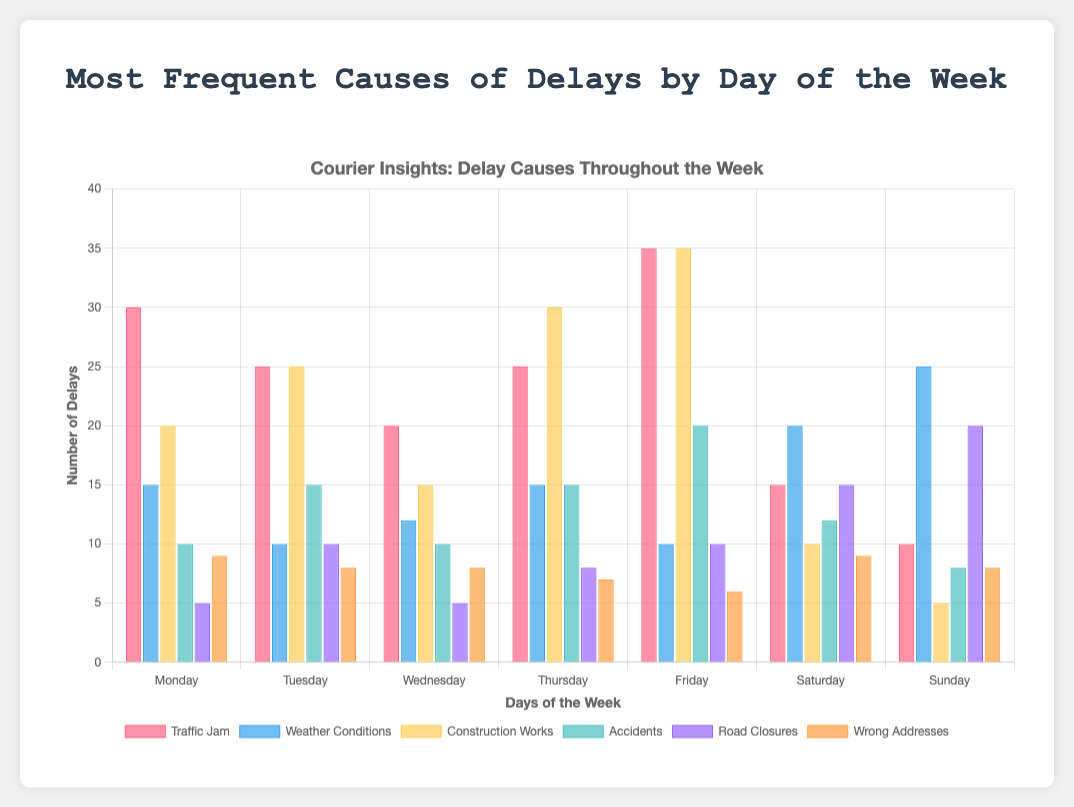What is the most frequent cause of delays on Monday? By looking at the height of the bars for Monday, the tallest bar represents "Traffic Jam" with a frequency of 30.
Answer: Traffic Jam Which day has the highest number of delays caused by Weather Conditions? By comparing the heights of the bars for Weather Conditions across all days, Sunday has the tallest bar with a frequency of 25.
Answer: Sunday What is the total number of delays caused by Construction Works from Monday to Sunday? Sum up the values for Construction Works across all days: 20 + 25 + 15 + 30 + 35 + 10 + 5 = 140.
Answer: 140 Between Tuesday and Thursday, which day has more delays due to Accidents? Compare the heights of the bars for Accidents on Tuesday (15) and Thursday (15). Both are equal.
Answer: Equal How do the number of delays due to Wrong Addresses compare between Monday and Saturday? Compare the height of the bars for Wrong Addresses on Monday (9) and Saturday (9). Both are equal.
Answer: Equal Which cause of delay has the least frequency on Sunday? By looking at the heights of all bars for Sunday, the shortest bar represents Construction Works with a frequency of 5.
Answer: Construction Works What is the average number of delays caused by Road Closures across the week? Sum up all values for Road Closures and divide by 7: (5 + 10 + 5 + 8 + 10 + 15 + 20) / 7 = 73 / 7 ≈ 10.43.
Answer: 10.43 On which day does Traffic Jam cause the smallest number of delays? Compare the height of the bars for Traffic Jam across all days. The shortest bar is on Sunday, with a frequency of 10.
Answer: Sunday If the frequencies of delays due to Construction Works on Wednesday and Friday are combined, what would be the total? Add the values for Construction Works on Wednesday (15) and Friday (35): 15 + 35 = 50.
Answer: 50 Which cause of delays is more frequent on Thursday, Construction Works or Weather Conditions? Compare the height of the bars for Construction Works (30) and Weather Conditions (15) on Thursday. Construction Works is higher.
Answer: Construction Works 